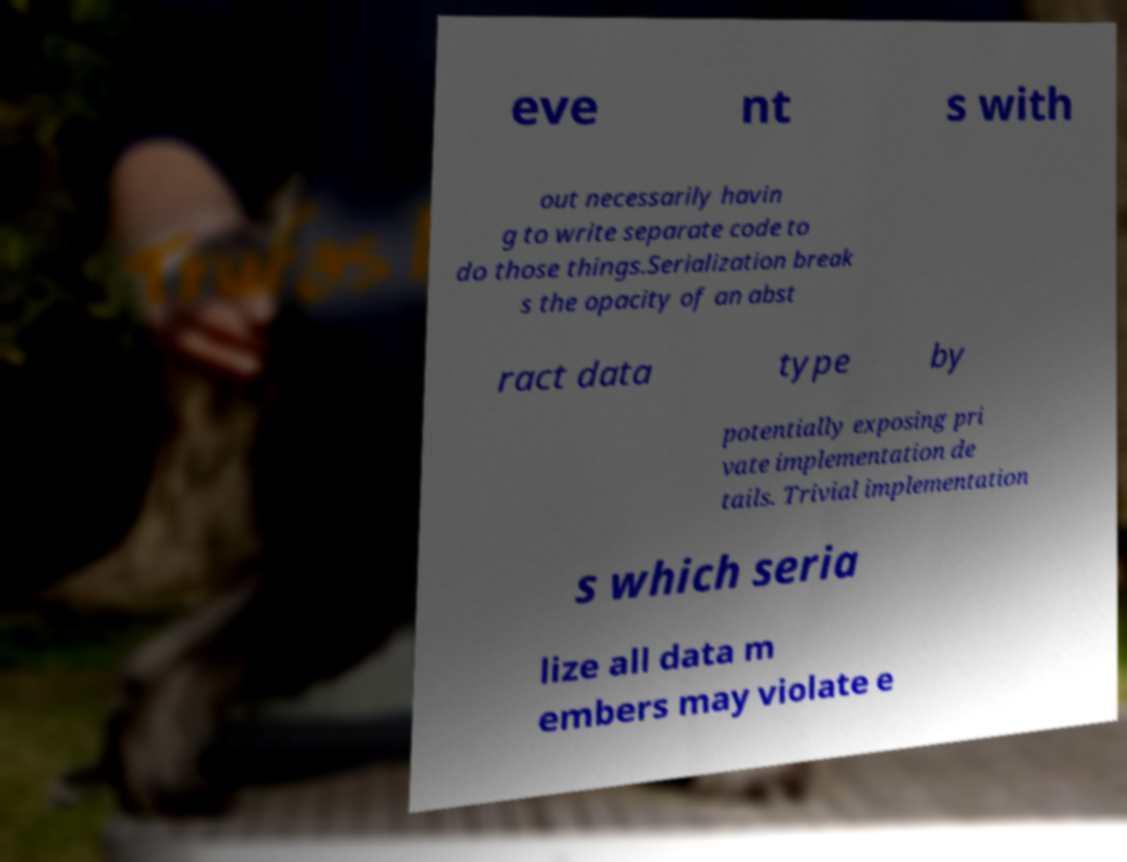Could you extract and type out the text from this image? eve nt s with out necessarily havin g to write separate code to do those things.Serialization break s the opacity of an abst ract data type by potentially exposing pri vate implementation de tails. Trivial implementation s which seria lize all data m embers may violate e 